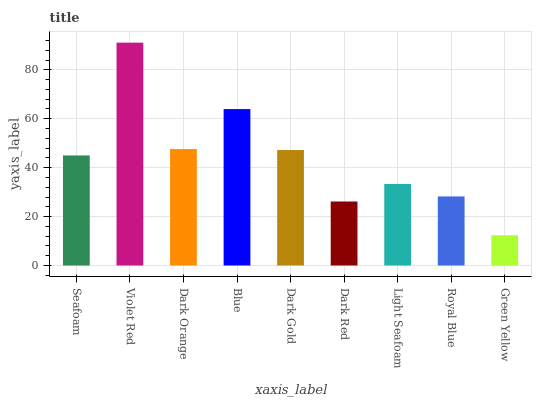Is Green Yellow the minimum?
Answer yes or no. Yes. Is Violet Red the maximum?
Answer yes or no. Yes. Is Dark Orange the minimum?
Answer yes or no. No. Is Dark Orange the maximum?
Answer yes or no. No. Is Violet Red greater than Dark Orange?
Answer yes or no. Yes. Is Dark Orange less than Violet Red?
Answer yes or no. Yes. Is Dark Orange greater than Violet Red?
Answer yes or no. No. Is Violet Red less than Dark Orange?
Answer yes or no. No. Is Seafoam the high median?
Answer yes or no. Yes. Is Seafoam the low median?
Answer yes or no. Yes. Is Violet Red the high median?
Answer yes or no. No. Is Royal Blue the low median?
Answer yes or no. No. 